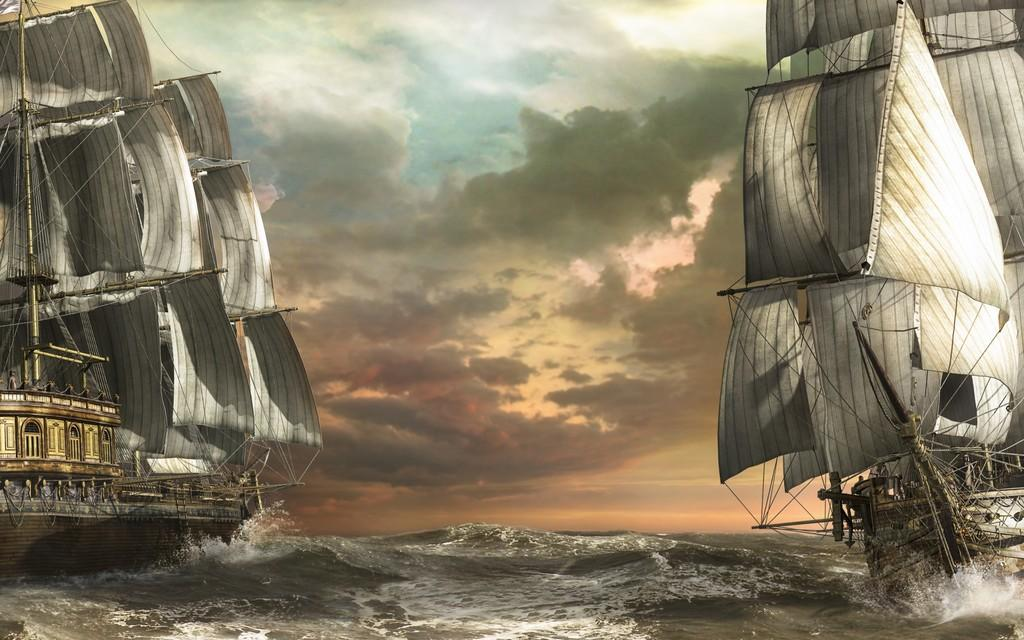What is located at the bottom of the image? There is a river at the bottom of the image. What can be seen in the river? There are two ships in the river. What is inside the ships? There are objects inside the ships. What is visible in the background of the image? There is sky visible in the background of the image. Where is the heart-shaped jelly located in the image? There is no heart-shaped jelly present in the image. What type of chair can be seen on the ships in the image? There are no chairs visible on the ships in the image. 